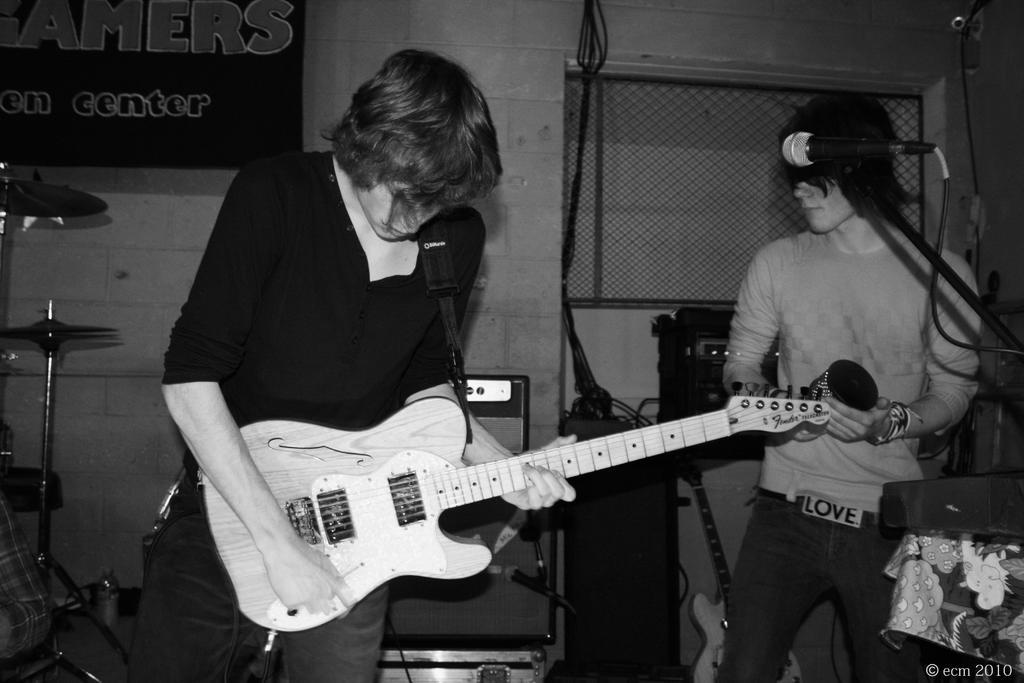How many people are in the image? There are two persons in the image. What are the persons in the image doing? Both persons are playing musical instruments. What type of kite can be seen in the image? There is no kite present in the image; the two persons are playing musical instruments. How comfortable are the chairs in the image? There is no mention of chairs in the image, so it is impossible to determine their comfort. 